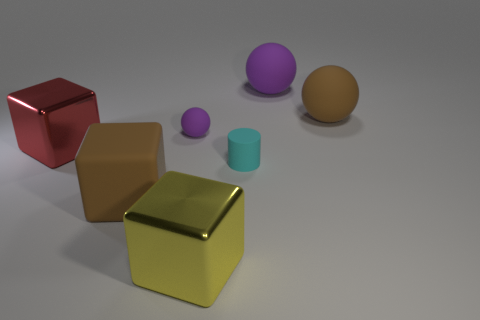How many things are either metallic cubes on the right side of the large red thing or purple spheres?
Keep it short and to the point. 3. How many objects are either big yellow metal cubes or things to the right of the small purple sphere?
Provide a succinct answer. 4. How many other cubes have the same size as the red cube?
Your answer should be compact. 2. Is the number of yellow blocks that are behind the big yellow metallic thing less than the number of tiny rubber things that are in front of the cyan thing?
Provide a short and direct response. No. What number of metallic things are small purple cubes or cyan cylinders?
Keep it short and to the point. 0. What shape is the yellow thing?
Your answer should be compact. Cube. There is a brown ball that is the same size as the yellow metal thing; what material is it?
Ensure brevity in your answer.  Rubber. What number of big things are objects or cyan objects?
Ensure brevity in your answer.  5. Are any small spheres visible?
Keep it short and to the point. Yes. The red thing that is made of the same material as the big yellow cube is what size?
Provide a succinct answer. Large. 